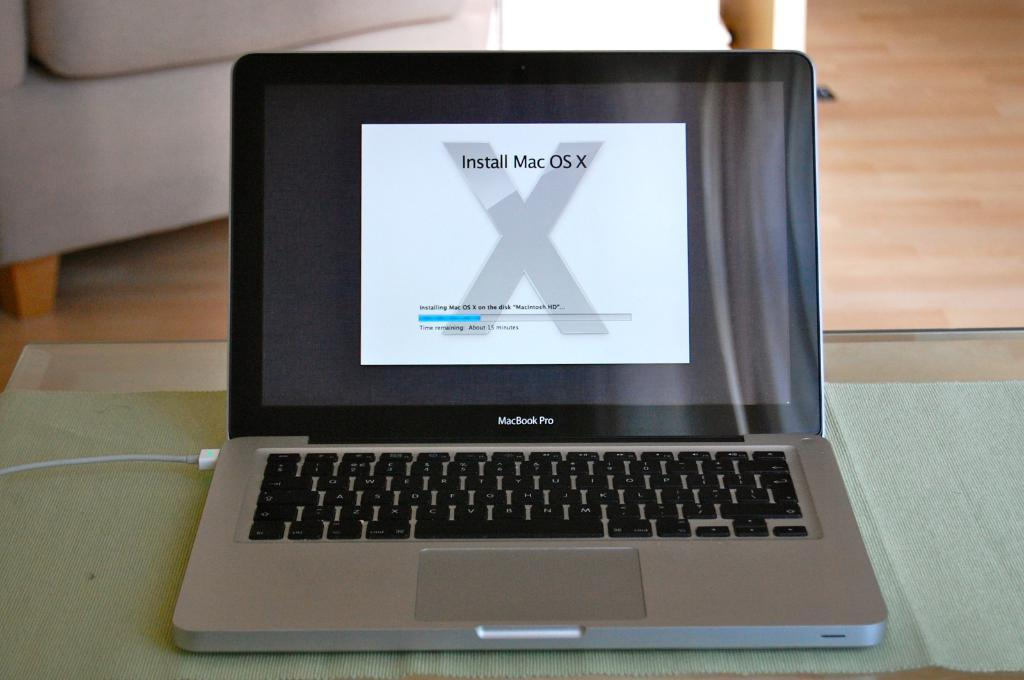Provide a one-sentence caption for the provided image. Macbook Pro sitting on a table with a prompt to install Mac OS X. 